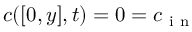Convert formula to latex. <formula><loc_0><loc_0><loc_500><loc_500>c ( [ 0 , y ] , t ) = 0 = c _ { i n }</formula> 